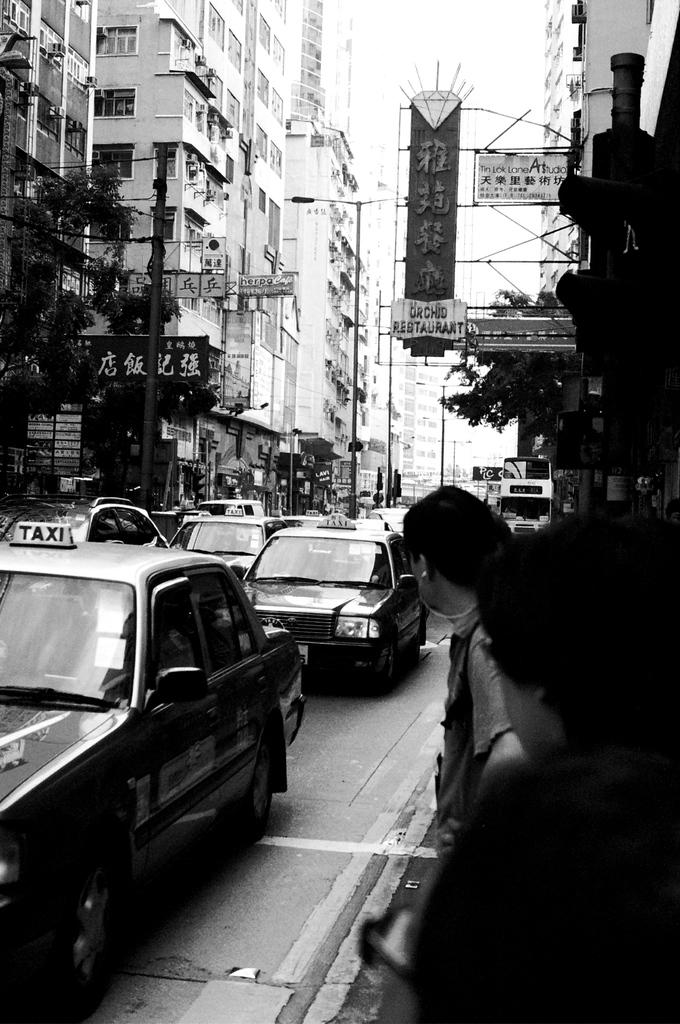<image>
Share a concise interpretation of the image provided. The Orchid Restaurant has a sign hanging out over a sidewalk. 